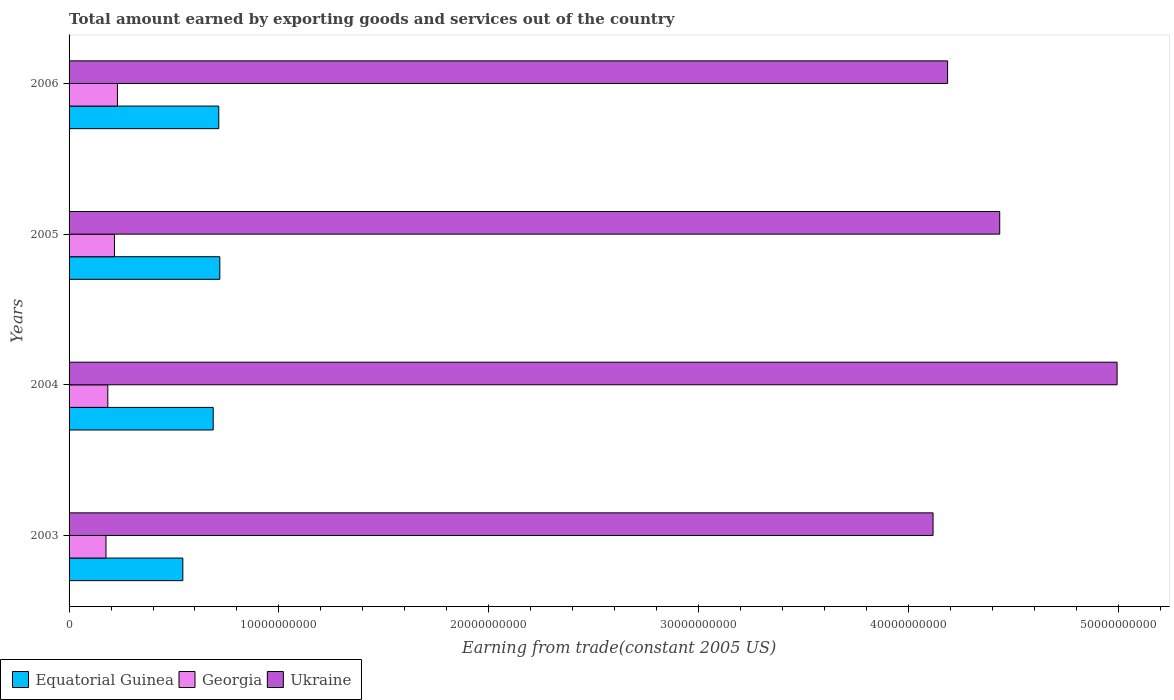How many different coloured bars are there?
Your response must be concise. 3. Are the number of bars on each tick of the Y-axis equal?
Your answer should be very brief. Yes. How many bars are there on the 1st tick from the bottom?
Offer a terse response. 3. What is the total amount earned by exporting goods and services in Ukraine in 2003?
Your answer should be very brief. 4.12e+1. Across all years, what is the maximum total amount earned by exporting goods and services in Equatorial Guinea?
Your answer should be very brief. 7.18e+09. Across all years, what is the minimum total amount earned by exporting goods and services in Equatorial Guinea?
Your answer should be very brief. 5.42e+09. In which year was the total amount earned by exporting goods and services in Ukraine minimum?
Give a very brief answer. 2003. What is the total total amount earned by exporting goods and services in Equatorial Guinea in the graph?
Your answer should be very brief. 2.66e+1. What is the difference between the total amount earned by exporting goods and services in Equatorial Guinea in 2003 and that in 2004?
Make the answer very short. -1.45e+09. What is the difference between the total amount earned by exporting goods and services in Georgia in 2004 and the total amount earned by exporting goods and services in Equatorial Guinea in 2003?
Provide a short and direct response. -3.57e+09. What is the average total amount earned by exporting goods and services in Equatorial Guinea per year?
Your answer should be very brief. 6.65e+09. In the year 2006, what is the difference between the total amount earned by exporting goods and services in Equatorial Guinea and total amount earned by exporting goods and services in Georgia?
Offer a very short reply. 4.83e+09. In how many years, is the total amount earned by exporting goods and services in Equatorial Guinea greater than 32000000000 US$?
Make the answer very short. 0. What is the ratio of the total amount earned by exporting goods and services in Ukraine in 2004 to that in 2006?
Provide a short and direct response. 1.19. Is the difference between the total amount earned by exporting goods and services in Equatorial Guinea in 2005 and 2006 greater than the difference between the total amount earned by exporting goods and services in Georgia in 2005 and 2006?
Provide a succinct answer. Yes. What is the difference between the highest and the second highest total amount earned by exporting goods and services in Equatorial Guinea?
Offer a terse response. 5.07e+07. What is the difference between the highest and the lowest total amount earned by exporting goods and services in Equatorial Guinea?
Give a very brief answer. 1.76e+09. In how many years, is the total amount earned by exporting goods and services in Ukraine greater than the average total amount earned by exporting goods and services in Ukraine taken over all years?
Offer a terse response. 2. Is the sum of the total amount earned by exporting goods and services in Georgia in 2004 and 2006 greater than the maximum total amount earned by exporting goods and services in Equatorial Guinea across all years?
Your answer should be very brief. No. What does the 1st bar from the top in 2003 represents?
Keep it short and to the point. Ukraine. What does the 3rd bar from the bottom in 2004 represents?
Offer a very short reply. Ukraine. How many bars are there?
Provide a short and direct response. 12. How many years are there in the graph?
Offer a very short reply. 4. Does the graph contain any zero values?
Provide a short and direct response. No. Where does the legend appear in the graph?
Your answer should be compact. Bottom left. How are the legend labels stacked?
Offer a very short reply. Horizontal. What is the title of the graph?
Your response must be concise. Total amount earned by exporting goods and services out of the country. What is the label or title of the X-axis?
Offer a terse response. Earning from trade(constant 2005 US). What is the Earning from trade(constant 2005 US) of Equatorial Guinea in 2003?
Offer a terse response. 5.42e+09. What is the Earning from trade(constant 2005 US) of Georgia in 2003?
Provide a short and direct response. 1.76e+09. What is the Earning from trade(constant 2005 US) of Ukraine in 2003?
Offer a terse response. 4.12e+1. What is the Earning from trade(constant 2005 US) in Equatorial Guinea in 2004?
Offer a terse response. 6.87e+09. What is the Earning from trade(constant 2005 US) in Georgia in 2004?
Provide a succinct answer. 1.85e+09. What is the Earning from trade(constant 2005 US) of Ukraine in 2004?
Offer a very short reply. 4.99e+1. What is the Earning from trade(constant 2005 US) in Equatorial Guinea in 2005?
Provide a succinct answer. 7.18e+09. What is the Earning from trade(constant 2005 US) of Georgia in 2005?
Offer a terse response. 2.16e+09. What is the Earning from trade(constant 2005 US) of Ukraine in 2005?
Provide a succinct answer. 4.43e+1. What is the Earning from trade(constant 2005 US) of Equatorial Guinea in 2006?
Offer a terse response. 7.13e+09. What is the Earning from trade(constant 2005 US) of Georgia in 2006?
Offer a terse response. 2.30e+09. What is the Earning from trade(constant 2005 US) in Ukraine in 2006?
Your answer should be very brief. 4.19e+1. Across all years, what is the maximum Earning from trade(constant 2005 US) in Equatorial Guinea?
Provide a short and direct response. 7.18e+09. Across all years, what is the maximum Earning from trade(constant 2005 US) of Georgia?
Provide a succinct answer. 2.30e+09. Across all years, what is the maximum Earning from trade(constant 2005 US) of Ukraine?
Give a very brief answer. 4.99e+1. Across all years, what is the minimum Earning from trade(constant 2005 US) in Equatorial Guinea?
Offer a terse response. 5.42e+09. Across all years, what is the minimum Earning from trade(constant 2005 US) of Georgia?
Your answer should be compact. 1.76e+09. Across all years, what is the minimum Earning from trade(constant 2005 US) in Ukraine?
Ensure brevity in your answer.  4.12e+1. What is the total Earning from trade(constant 2005 US) in Equatorial Guinea in the graph?
Offer a very short reply. 2.66e+1. What is the total Earning from trade(constant 2005 US) of Georgia in the graph?
Your response must be concise. 8.07e+09. What is the total Earning from trade(constant 2005 US) in Ukraine in the graph?
Give a very brief answer. 1.77e+11. What is the difference between the Earning from trade(constant 2005 US) of Equatorial Guinea in 2003 and that in 2004?
Keep it short and to the point. -1.45e+09. What is the difference between the Earning from trade(constant 2005 US) of Georgia in 2003 and that in 2004?
Provide a short and direct response. -8.66e+07. What is the difference between the Earning from trade(constant 2005 US) of Ukraine in 2003 and that in 2004?
Keep it short and to the point. -8.77e+09. What is the difference between the Earning from trade(constant 2005 US) in Equatorial Guinea in 2003 and that in 2005?
Provide a short and direct response. -1.76e+09. What is the difference between the Earning from trade(constant 2005 US) in Georgia in 2003 and that in 2005?
Offer a terse response. -4.04e+08. What is the difference between the Earning from trade(constant 2005 US) in Ukraine in 2003 and that in 2005?
Provide a succinct answer. -3.18e+09. What is the difference between the Earning from trade(constant 2005 US) of Equatorial Guinea in 2003 and that in 2006?
Keep it short and to the point. -1.71e+09. What is the difference between the Earning from trade(constant 2005 US) in Georgia in 2003 and that in 2006?
Ensure brevity in your answer.  -5.45e+08. What is the difference between the Earning from trade(constant 2005 US) in Ukraine in 2003 and that in 2006?
Your answer should be very brief. -6.93e+08. What is the difference between the Earning from trade(constant 2005 US) of Equatorial Guinea in 2004 and that in 2005?
Give a very brief answer. -3.16e+08. What is the difference between the Earning from trade(constant 2005 US) of Georgia in 2004 and that in 2005?
Provide a short and direct response. -3.18e+08. What is the difference between the Earning from trade(constant 2005 US) in Ukraine in 2004 and that in 2005?
Make the answer very short. 5.59e+09. What is the difference between the Earning from trade(constant 2005 US) in Equatorial Guinea in 2004 and that in 2006?
Offer a very short reply. -2.65e+08. What is the difference between the Earning from trade(constant 2005 US) of Georgia in 2004 and that in 2006?
Your answer should be compact. -4.59e+08. What is the difference between the Earning from trade(constant 2005 US) in Ukraine in 2004 and that in 2006?
Offer a terse response. 8.08e+09. What is the difference between the Earning from trade(constant 2005 US) in Equatorial Guinea in 2005 and that in 2006?
Ensure brevity in your answer.  5.07e+07. What is the difference between the Earning from trade(constant 2005 US) in Georgia in 2005 and that in 2006?
Provide a succinct answer. -1.41e+08. What is the difference between the Earning from trade(constant 2005 US) in Ukraine in 2005 and that in 2006?
Ensure brevity in your answer.  2.48e+09. What is the difference between the Earning from trade(constant 2005 US) in Equatorial Guinea in 2003 and the Earning from trade(constant 2005 US) in Georgia in 2004?
Your response must be concise. 3.57e+09. What is the difference between the Earning from trade(constant 2005 US) of Equatorial Guinea in 2003 and the Earning from trade(constant 2005 US) of Ukraine in 2004?
Ensure brevity in your answer.  -4.45e+1. What is the difference between the Earning from trade(constant 2005 US) in Georgia in 2003 and the Earning from trade(constant 2005 US) in Ukraine in 2004?
Your answer should be very brief. -4.82e+1. What is the difference between the Earning from trade(constant 2005 US) of Equatorial Guinea in 2003 and the Earning from trade(constant 2005 US) of Georgia in 2005?
Ensure brevity in your answer.  3.26e+09. What is the difference between the Earning from trade(constant 2005 US) of Equatorial Guinea in 2003 and the Earning from trade(constant 2005 US) of Ukraine in 2005?
Make the answer very short. -3.89e+1. What is the difference between the Earning from trade(constant 2005 US) in Georgia in 2003 and the Earning from trade(constant 2005 US) in Ukraine in 2005?
Give a very brief answer. -4.26e+1. What is the difference between the Earning from trade(constant 2005 US) of Equatorial Guinea in 2003 and the Earning from trade(constant 2005 US) of Georgia in 2006?
Your answer should be very brief. 3.12e+09. What is the difference between the Earning from trade(constant 2005 US) of Equatorial Guinea in 2003 and the Earning from trade(constant 2005 US) of Ukraine in 2006?
Keep it short and to the point. -3.64e+1. What is the difference between the Earning from trade(constant 2005 US) in Georgia in 2003 and the Earning from trade(constant 2005 US) in Ukraine in 2006?
Offer a terse response. -4.01e+1. What is the difference between the Earning from trade(constant 2005 US) in Equatorial Guinea in 2004 and the Earning from trade(constant 2005 US) in Georgia in 2005?
Offer a terse response. 4.70e+09. What is the difference between the Earning from trade(constant 2005 US) of Equatorial Guinea in 2004 and the Earning from trade(constant 2005 US) of Ukraine in 2005?
Offer a very short reply. -3.75e+1. What is the difference between the Earning from trade(constant 2005 US) in Georgia in 2004 and the Earning from trade(constant 2005 US) in Ukraine in 2005?
Make the answer very short. -4.25e+1. What is the difference between the Earning from trade(constant 2005 US) of Equatorial Guinea in 2004 and the Earning from trade(constant 2005 US) of Georgia in 2006?
Ensure brevity in your answer.  4.56e+09. What is the difference between the Earning from trade(constant 2005 US) of Equatorial Guinea in 2004 and the Earning from trade(constant 2005 US) of Ukraine in 2006?
Your answer should be very brief. -3.50e+1. What is the difference between the Earning from trade(constant 2005 US) of Georgia in 2004 and the Earning from trade(constant 2005 US) of Ukraine in 2006?
Make the answer very short. -4.00e+1. What is the difference between the Earning from trade(constant 2005 US) in Equatorial Guinea in 2005 and the Earning from trade(constant 2005 US) in Georgia in 2006?
Give a very brief answer. 4.88e+09. What is the difference between the Earning from trade(constant 2005 US) of Equatorial Guinea in 2005 and the Earning from trade(constant 2005 US) of Ukraine in 2006?
Ensure brevity in your answer.  -3.47e+1. What is the difference between the Earning from trade(constant 2005 US) in Georgia in 2005 and the Earning from trade(constant 2005 US) in Ukraine in 2006?
Offer a terse response. -3.97e+1. What is the average Earning from trade(constant 2005 US) in Equatorial Guinea per year?
Make the answer very short. 6.65e+09. What is the average Earning from trade(constant 2005 US) in Georgia per year?
Offer a terse response. 2.02e+09. What is the average Earning from trade(constant 2005 US) in Ukraine per year?
Offer a very short reply. 4.43e+1. In the year 2003, what is the difference between the Earning from trade(constant 2005 US) of Equatorial Guinea and Earning from trade(constant 2005 US) of Georgia?
Your answer should be very brief. 3.66e+09. In the year 2003, what is the difference between the Earning from trade(constant 2005 US) of Equatorial Guinea and Earning from trade(constant 2005 US) of Ukraine?
Your response must be concise. -3.57e+1. In the year 2003, what is the difference between the Earning from trade(constant 2005 US) of Georgia and Earning from trade(constant 2005 US) of Ukraine?
Keep it short and to the point. -3.94e+1. In the year 2004, what is the difference between the Earning from trade(constant 2005 US) of Equatorial Guinea and Earning from trade(constant 2005 US) of Georgia?
Ensure brevity in your answer.  5.02e+09. In the year 2004, what is the difference between the Earning from trade(constant 2005 US) of Equatorial Guinea and Earning from trade(constant 2005 US) of Ukraine?
Give a very brief answer. -4.31e+1. In the year 2004, what is the difference between the Earning from trade(constant 2005 US) of Georgia and Earning from trade(constant 2005 US) of Ukraine?
Ensure brevity in your answer.  -4.81e+1. In the year 2005, what is the difference between the Earning from trade(constant 2005 US) in Equatorial Guinea and Earning from trade(constant 2005 US) in Georgia?
Your response must be concise. 5.02e+09. In the year 2005, what is the difference between the Earning from trade(constant 2005 US) of Equatorial Guinea and Earning from trade(constant 2005 US) of Ukraine?
Provide a succinct answer. -3.72e+1. In the year 2005, what is the difference between the Earning from trade(constant 2005 US) in Georgia and Earning from trade(constant 2005 US) in Ukraine?
Give a very brief answer. -4.22e+1. In the year 2006, what is the difference between the Earning from trade(constant 2005 US) of Equatorial Guinea and Earning from trade(constant 2005 US) of Georgia?
Give a very brief answer. 4.83e+09. In the year 2006, what is the difference between the Earning from trade(constant 2005 US) in Equatorial Guinea and Earning from trade(constant 2005 US) in Ukraine?
Ensure brevity in your answer.  -3.47e+1. In the year 2006, what is the difference between the Earning from trade(constant 2005 US) of Georgia and Earning from trade(constant 2005 US) of Ukraine?
Provide a succinct answer. -3.96e+1. What is the ratio of the Earning from trade(constant 2005 US) of Equatorial Guinea in 2003 to that in 2004?
Ensure brevity in your answer.  0.79. What is the ratio of the Earning from trade(constant 2005 US) of Georgia in 2003 to that in 2004?
Your answer should be compact. 0.95. What is the ratio of the Earning from trade(constant 2005 US) in Ukraine in 2003 to that in 2004?
Keep it short and to the point. 0.82. What is the ratio of the Earning from trade(constant 2005 US) of Equatorial Guinea in 2003 to that in 2005?
Keep it short and to the point. 0.75. What is the ratio of the Earning from trade(constant 2005 US) of Georgia in 2003 to that in 2005?
Your response must be concise. 0.81. What is the ratio of the Earning from trade(constant 2005 US) in Ukraine in 2003 to that in 2005?
Give a very brief answer. 0.93. What is the ratio of the Earning from trade(constant 2005 US) of Equatorial Guinea in 2003 to that in 2006?
Keep it short and to the point. 0.76. What is the ratio of the Earning from trade(constant 2005 US) in Georgia in 2003 to that in 2006?
Your answer should be very brief. 0.76. What is the ratio of the Earning from trade(constant 2005 US) in Ukraine in 2003 to that in 2006?
Your response must be concise. 0.98. What is the ratio of the Earning from trade(constant 2005 US) in Equatorial Guinea in 2004 to that in 2005?
Your response must be concise. 0.96. What is the ratio of the Earning from trade(constant 2005 US) in Georgia in 2004 to that in 2005?
Your answer should be compact. 0.85. What is the ratio of the Earning from trade(constant 2005 US) of Ukraine in 2004 to that in 2005?
Ensure brevity in your answer.  1.13. What is the ratio of the Earning from trade(constant 2005 US) of Equatorial Guinea in 2004 to that in 2006?
Give a very brief answer. 0.96. What is the ratio of the Earning from trade(constant 2005 US) of Georgia in 2004 to that in 2006?
Provide a succinct answer. 0.8. What is the ratio of the Earning from trade(constant 2005 US) of Ukraine in 2004 to that in 2006?
Provide a succinct answer. 1.19. What is the ratio of the Earning from trade(constant 2005 US) in Equatorial Guinea in 2005 to that in 2006?
Offer a very short reply. 1.01. What is the ratio of the Earning from trade(constant 2005 US) of Georgia in 2005 to that in 2006?
Offer a terse response. 0.94. What is the ratio of the Earning from trade(constant 2005 US) in Ukraine in 2005 to that in 2006?
Give a very brief answer. 1.06. What is the difference between the highest and the second highest Earning from trade(constant 2005 US) of Equatorial Guinea?
Your answer should be compact. 5.07e+07. What is the difference between the highest and the second highest Earning from trade(constant 2005 US) of Georgia?
Offer a very short reply. 1.41e+08. What is the difference between the highest and the second highest Earning from trade(constant 2005 US) of Ukraine?
Your response must be concise. 5.59e+09. What is the difference between the highest and the lowest Earning from trade(constant 2005 US) in Equatorial Guinea?
Offer a terse response. 1.76e+09. What is the difference between the highest and the lowest Earning from trade(constant 2005 US) in Georgia?
Your answer should be compact. 5.45e+08. What is the difference between the highest and the lowest Earning from trade(constant 2005 US) in Ukraine?
Offer a very short reply. 8.77e+09. 